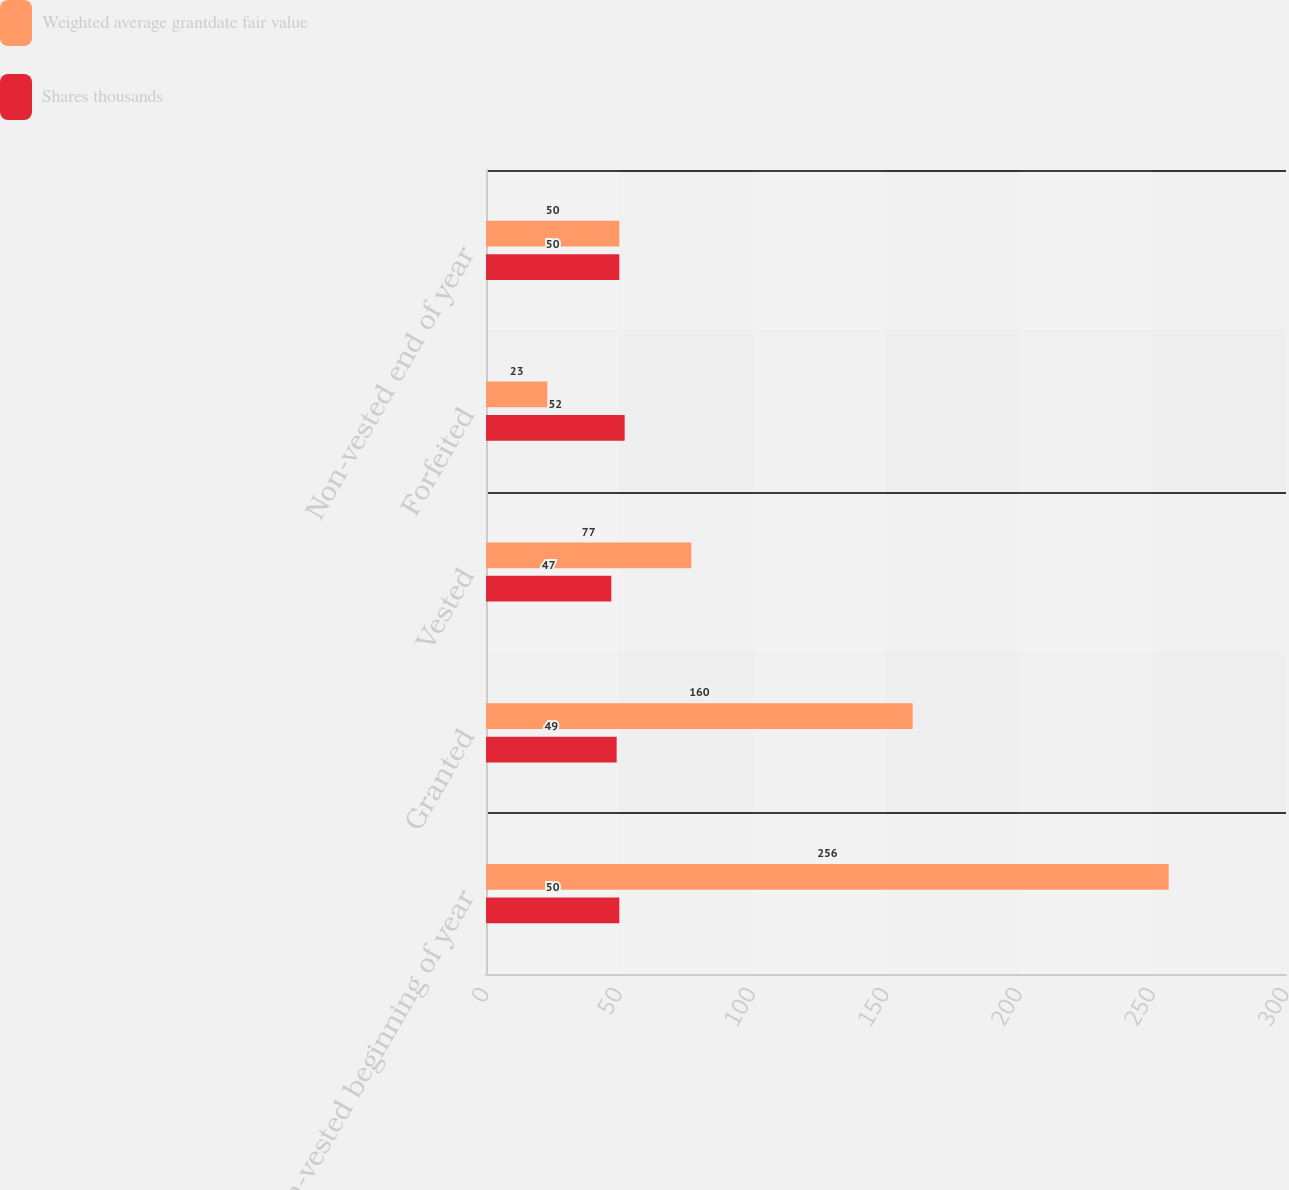Convert chart to OTSL. <chart><loc_0><loc_0><loc_500><loc_500><stacked_bar_chart><ecel><fcel>Non-vested beginning of year<fcel>Granted<fcel>Vested<fcel>Forfeited<fcel>Non-vested end of year<nl><fcel>Weighted average grantdate fair value<fcel>256<fcel>160<fcel>77<fcel>23<fcel>50<nl><fcel>Shares thousands<fcel>50<fcel>49<fcel>47<fcel>52<fcel>50<nl></chart> 